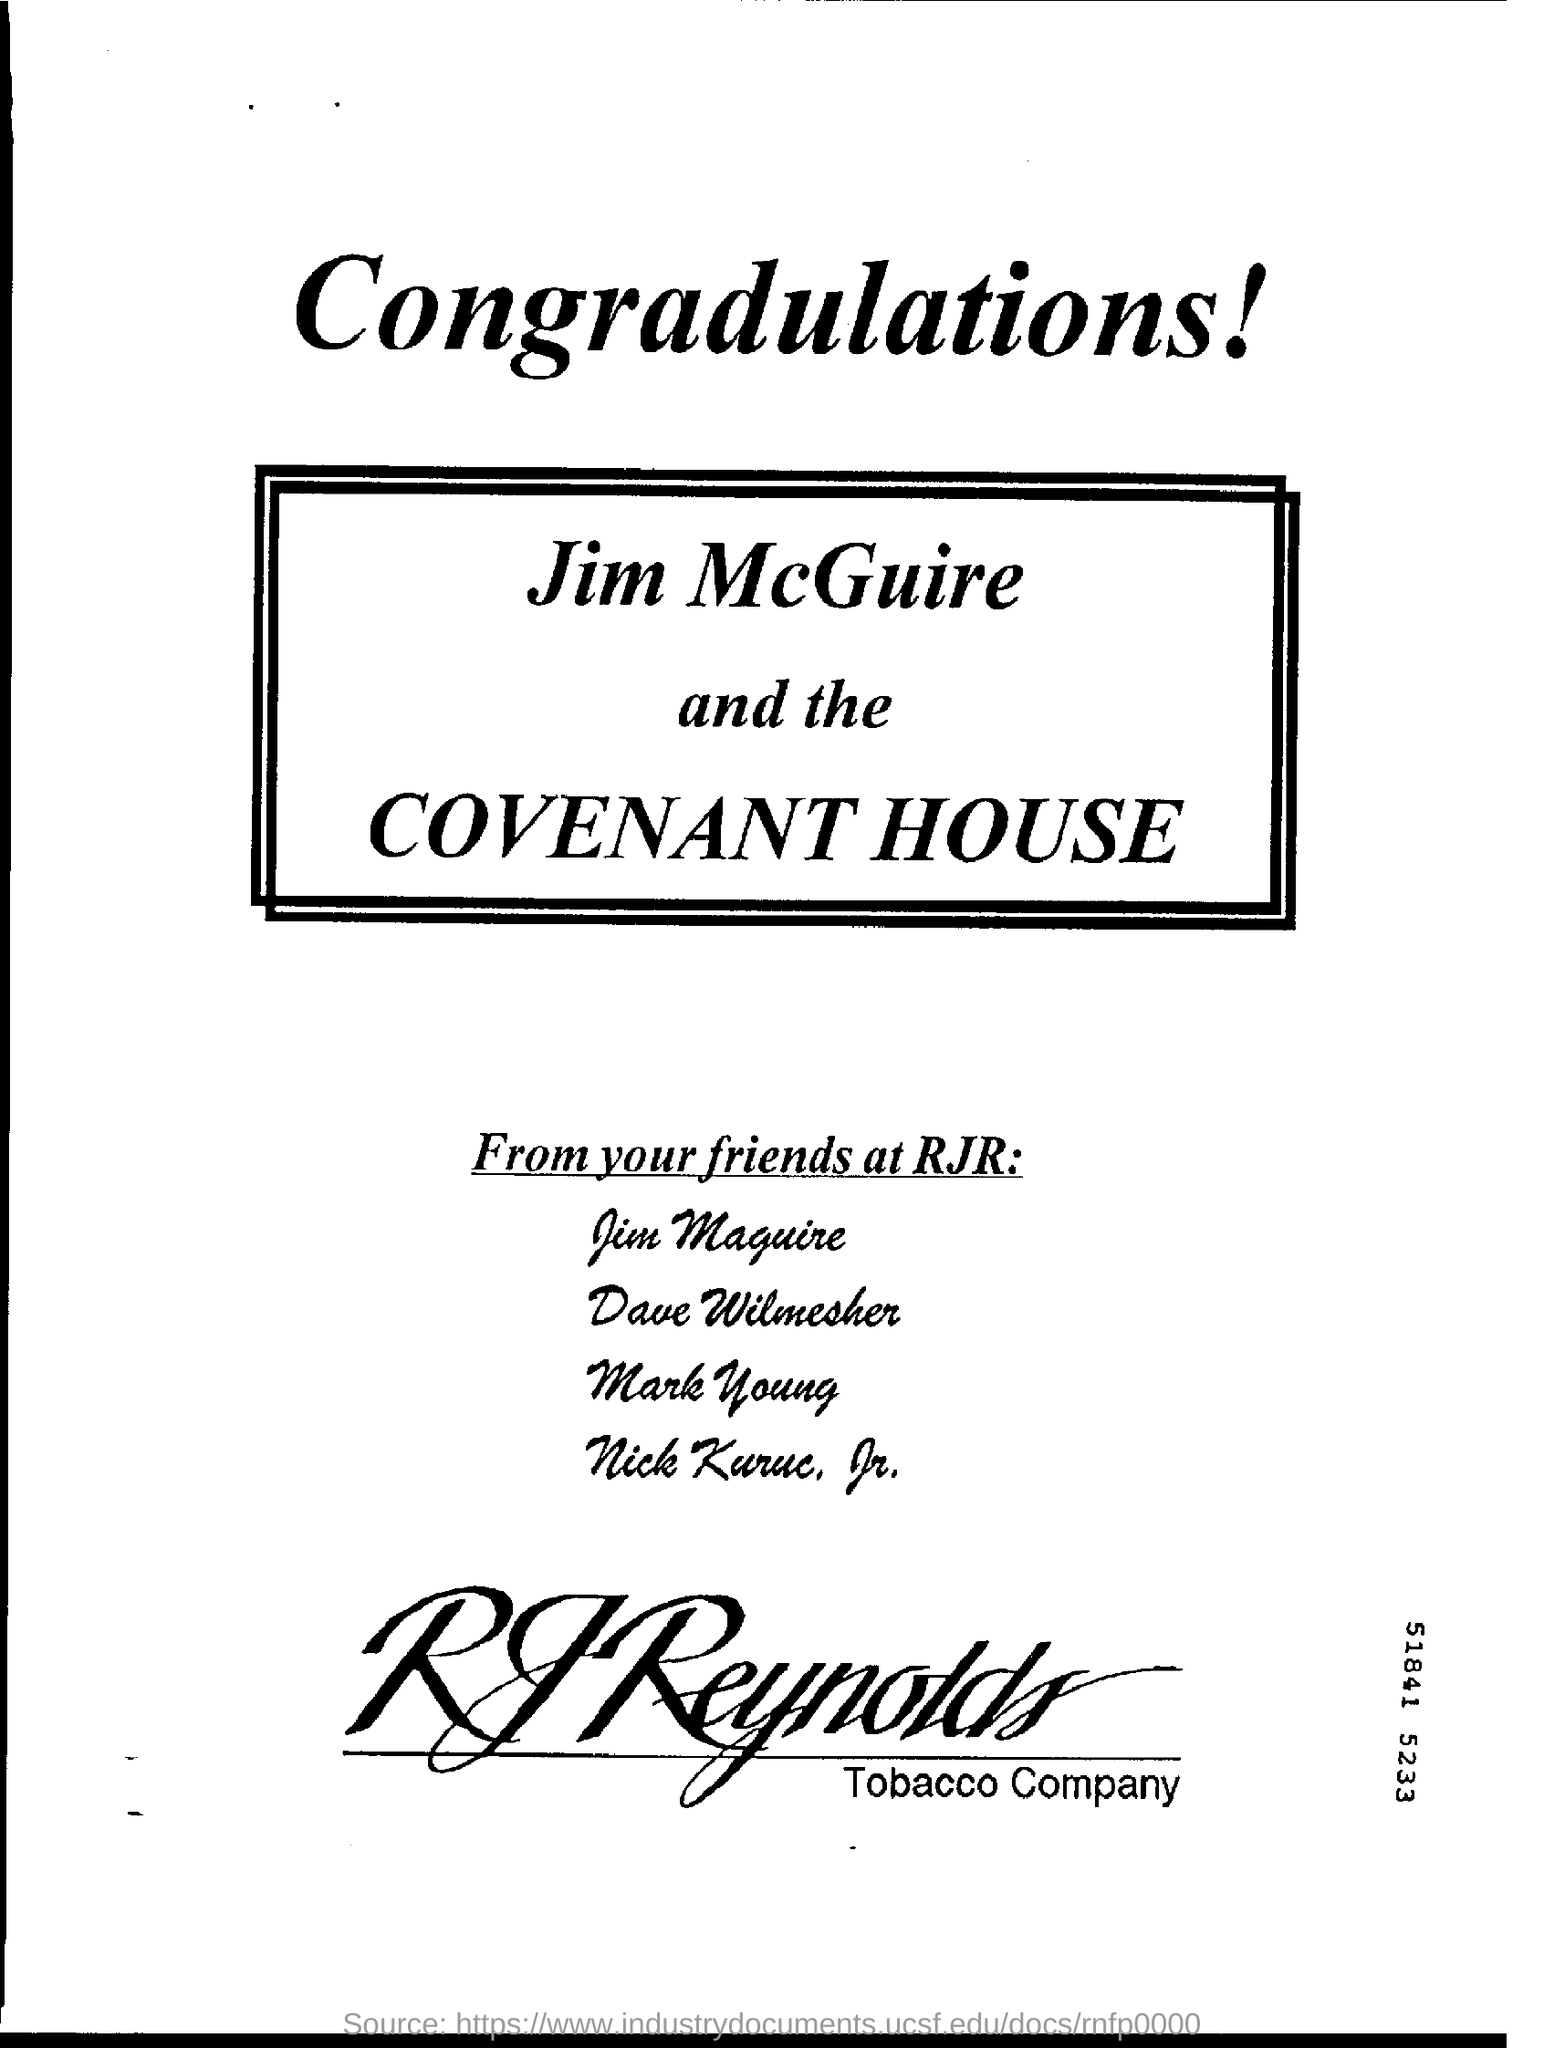What is the name of the tobacco company?
Ensure brevity in your answer.  RJReynolds. 